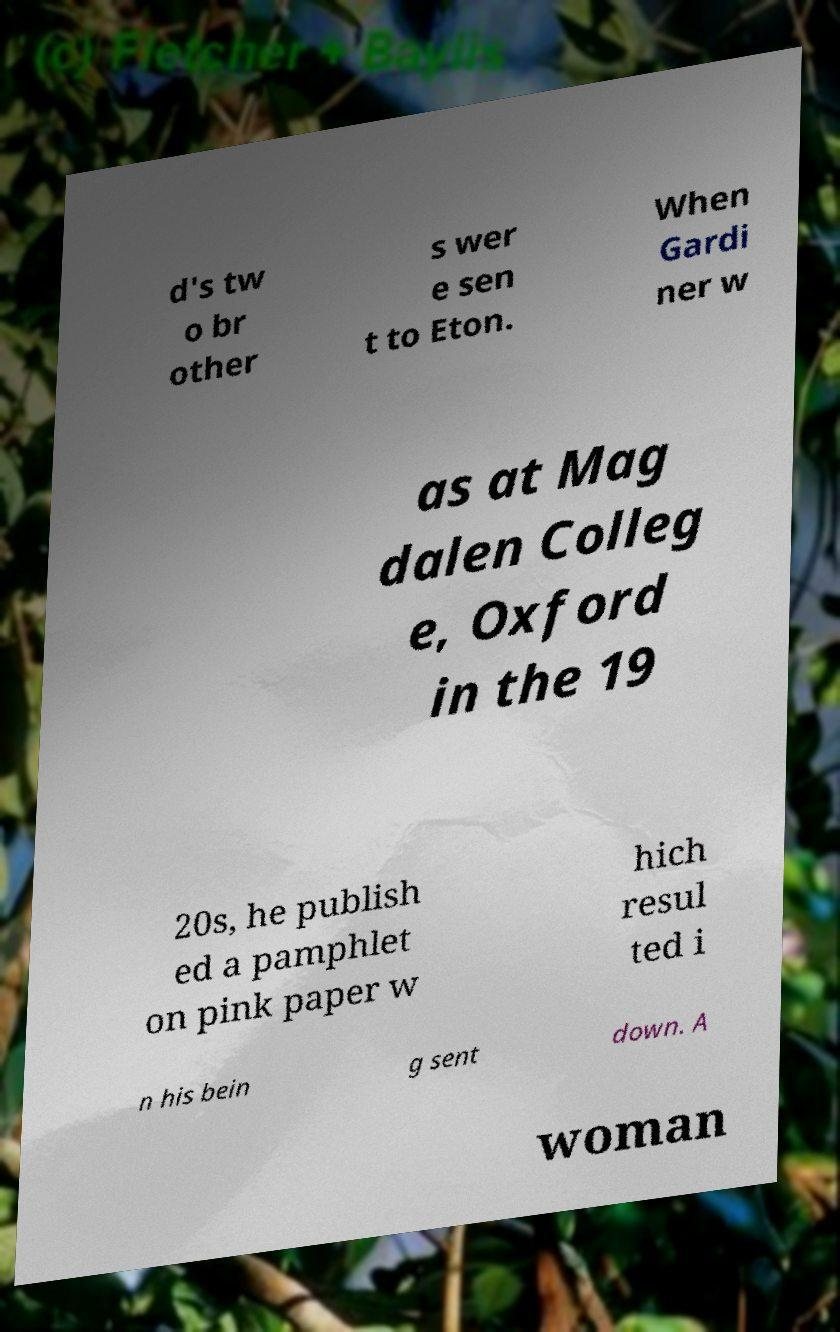Can you read and provide the text displayed in the image?This photo seems to have some interesting text. Can you extract and type it out for me? d's tw o br other s wer e sen t to Eton. When Gardi ner w as at Mag dalen Colleg e, Oxford in the 19 20s, he publish ed a pamphlet on pink paper w hich resul ted i n his bein g sent down. A woman 